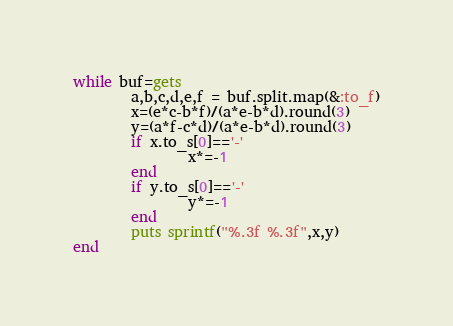<code> <loc_0><loc_0><loc_500><loc_500><_Ruby_>while buf=gets
        a,b,c,d,e,f = buf.split.map(&:to_f)
        x=(e*c-b*f)/(a*e-b*d).round(3)
        y=(a*f-c*d)/(a*e-b*d).round(3)
        if x.to_s[0]=='-'
                x*=-1
        end
        if y.to_s[0]=='-'
                y*=-1
        end
        puts sprintf("%.3f %.3f",x,y)
end</code> 